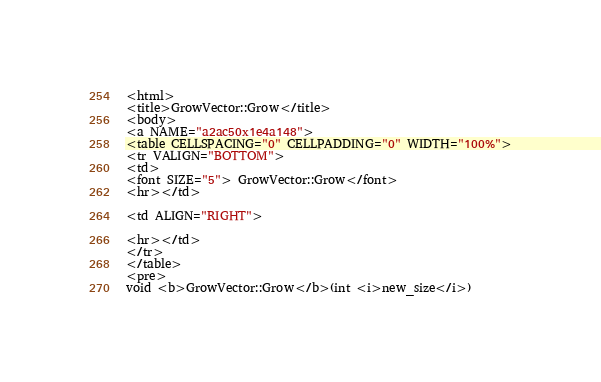<code> <loc_0><loc_0><loc_500><loc_500><_HTML_><html>
<title>GrowVector::Grow</title>
<body>
<a NAME="a2ac50x1e4a148">
<table CELLSPACING="0" CELLPADDING="0" WIDTH="100%">
<tr VALIGN="BOTTOM">
<td>
<font SIZE="5"> GrowVector::Grow</font>
<hr></td>

<td ALIGN="RIGHT">

<hr></td>
</tr>
</table>
<pre>
void <b>GrowVector::Grow</b>(int <i>new_size</i>)</code> 